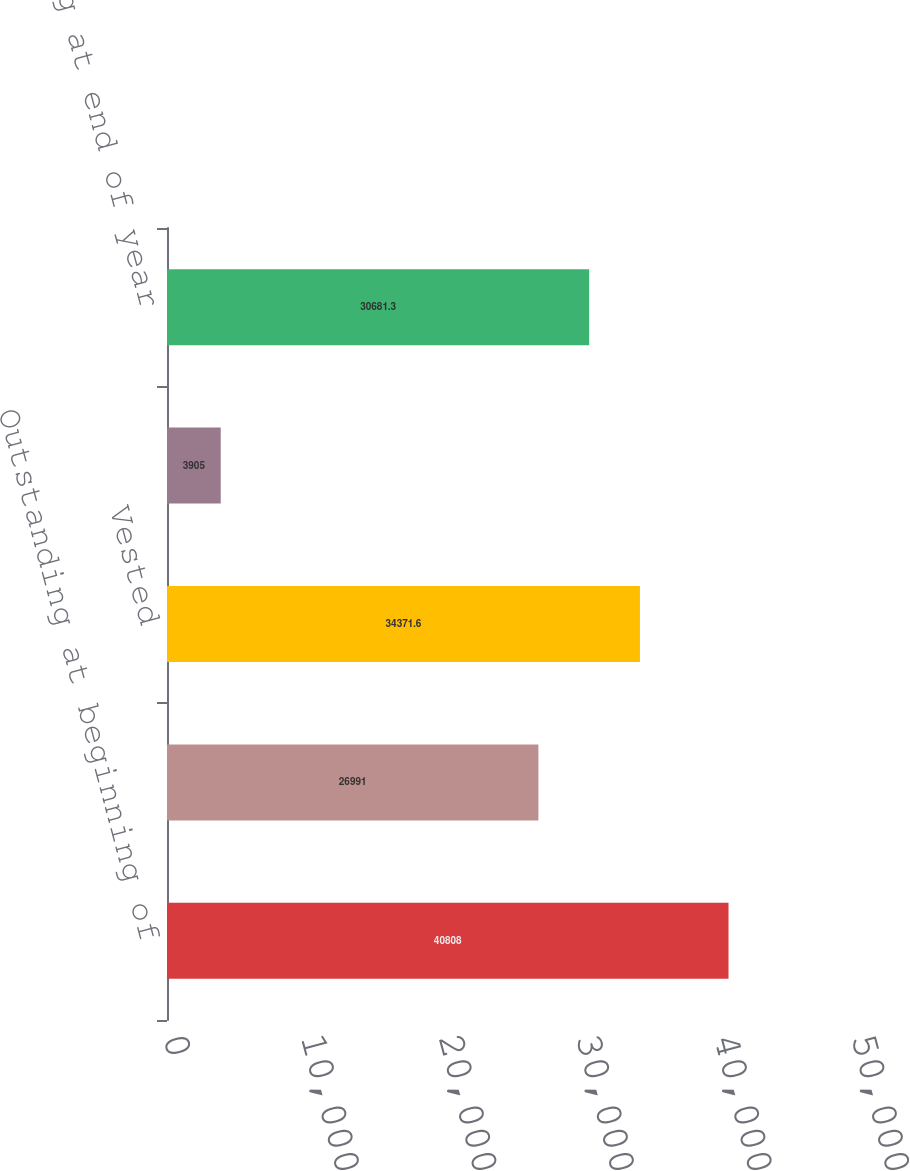Convert chart to OTSL. <chart><loc_0><loc_0><loc_500><loc_500><bar_chart><fcel>Outstanding at beginning of<fcel>Granted and assumed through<fcel>Vested<fcel>Forfeited<fcel>Outstanding at end of year<nl><fcel>40808<fcel>26991<fcel>34371.6<fcel>3905<fcel>30681.3<nl></chart> 